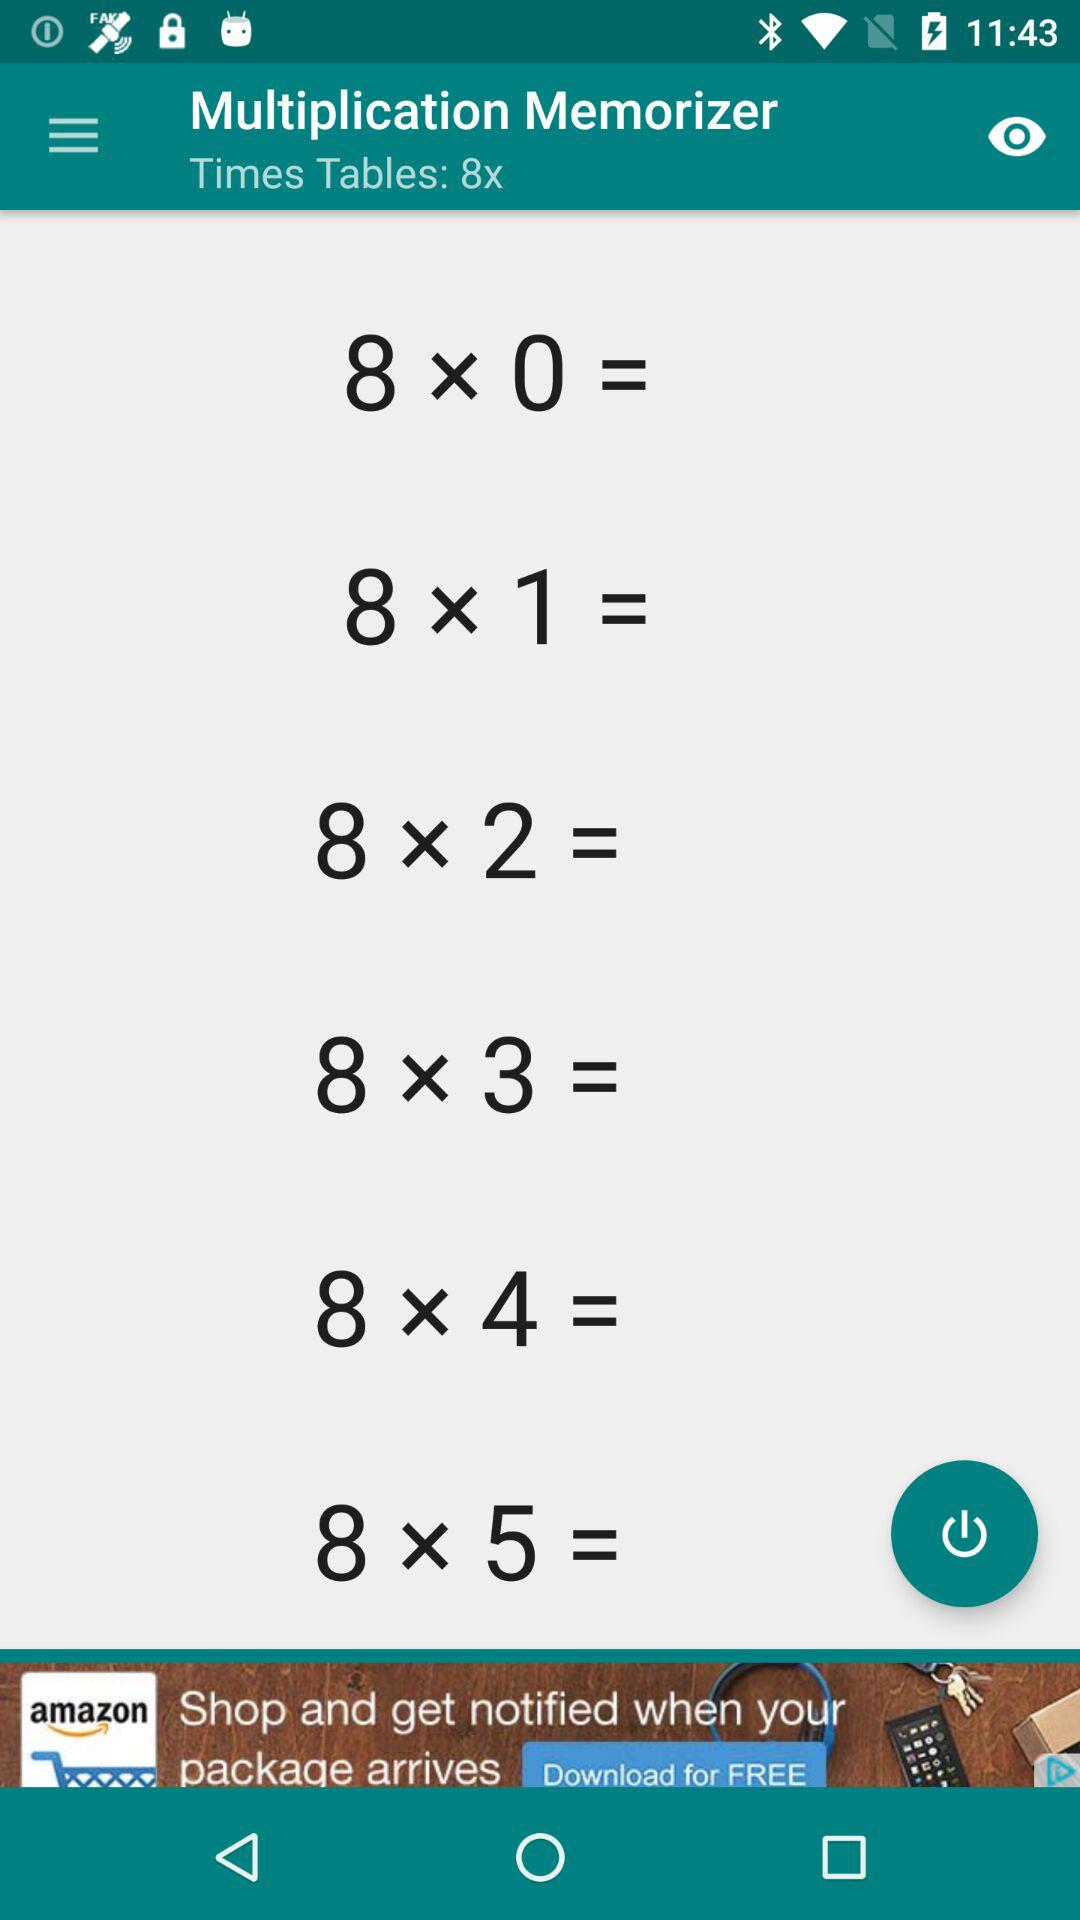How many times tables are displayed for the number 8?
Answer the question using a single word or phrase. 6 